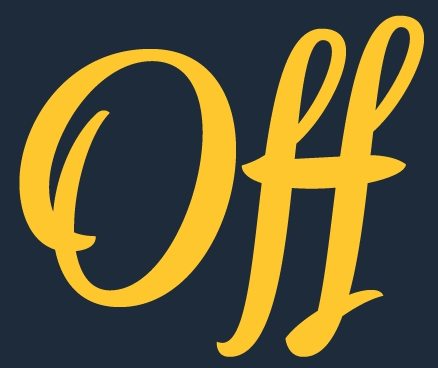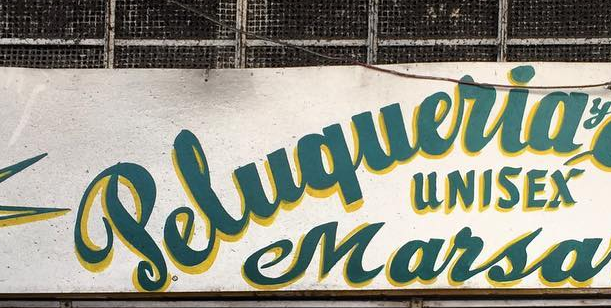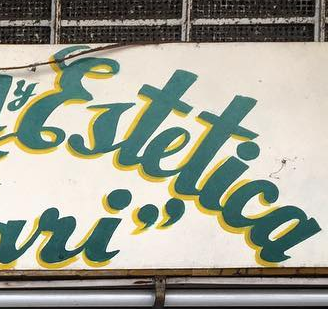What text appears in these images from left to right, separated by a semicolon? Off; Peluqueria; Ertetica 